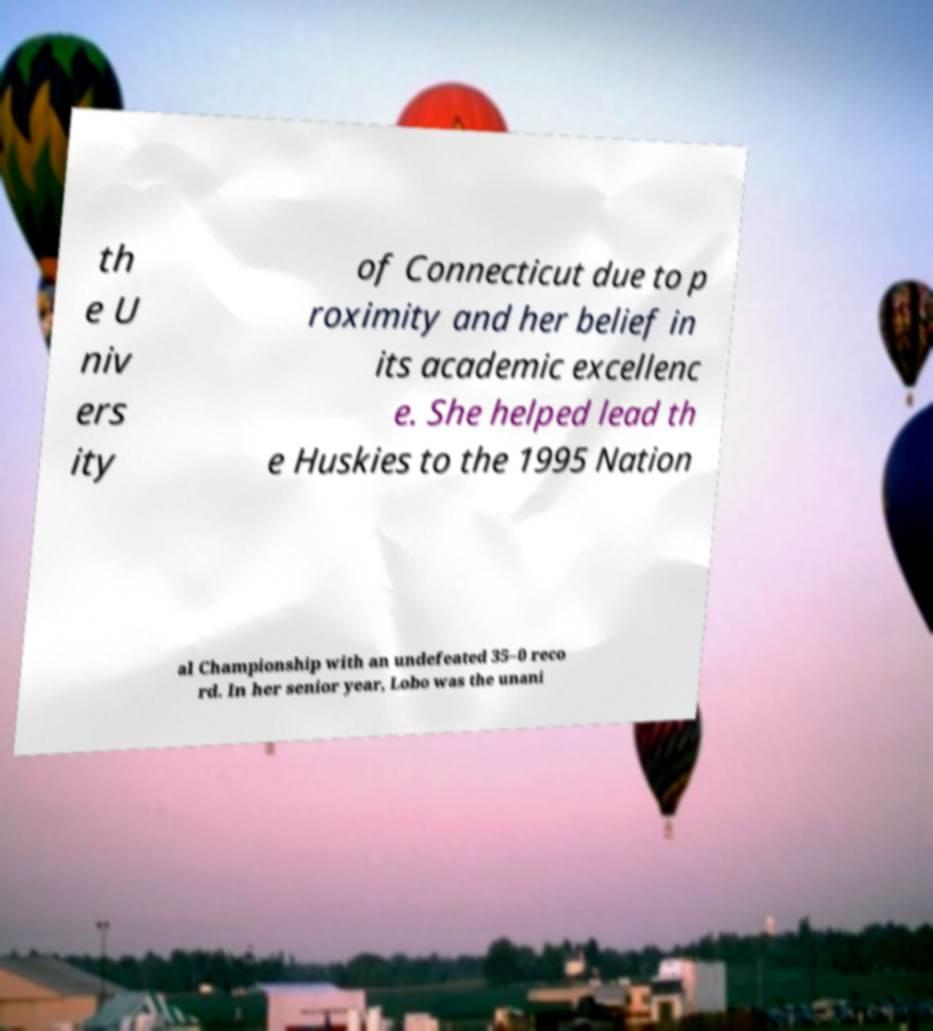There's text embedded in this image that I need extracted. Can you transcribe it verbatim? th e U niv ers ity of Connecticut due to p roximity and her belief in its academic excellenc e. She helped lead th e Huskies to the 1995 Nation al Championship with an undefeated 35–0 reco rd. In her senior year, Lobo was the unani 